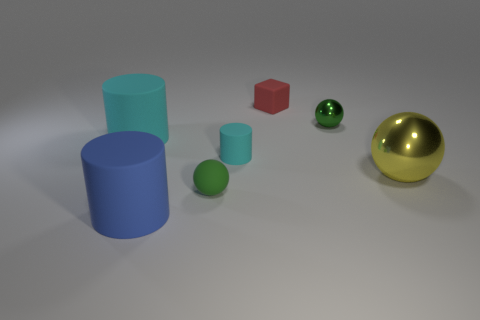What is the green sphere behind the big cylinder that is behind the tiny rubber cylinder made of?
Provide a succinct answer. Metal. There is a metal thing that is to the right of the tiny green object that is behind the cyan rubber cylinder in front of the large cyan rubber thing; what is its shape?
Offer a terse response. Sphere. There is a yellow object that is the same shape as the small green rubber thing; what material is it?
Offer a very short reply. Metal. What number of big spheres are there?
Provide a short and direct response. 1. There is a large rubber thing behind the green rubber ball; what is its shape?
Your response must be concise. Cylinder. What is the color of the small matte thing that is behind the green ball that is behind the large cylinder to the left of the large blue object?
Your answer should be very brief. Red. There is a blue object that is made of the same material as the small cyan object; what shape is it?
Provide a short and direct response. Cylinder. Is the number of things less than the number of small green shiny spheres?
Offer a terse response. No. Do the small cube and the large sphere have the same material?
Provide a short and direct response. No. What number of other things are the same color as the small metal object?
Offer a very short reply. 1. 